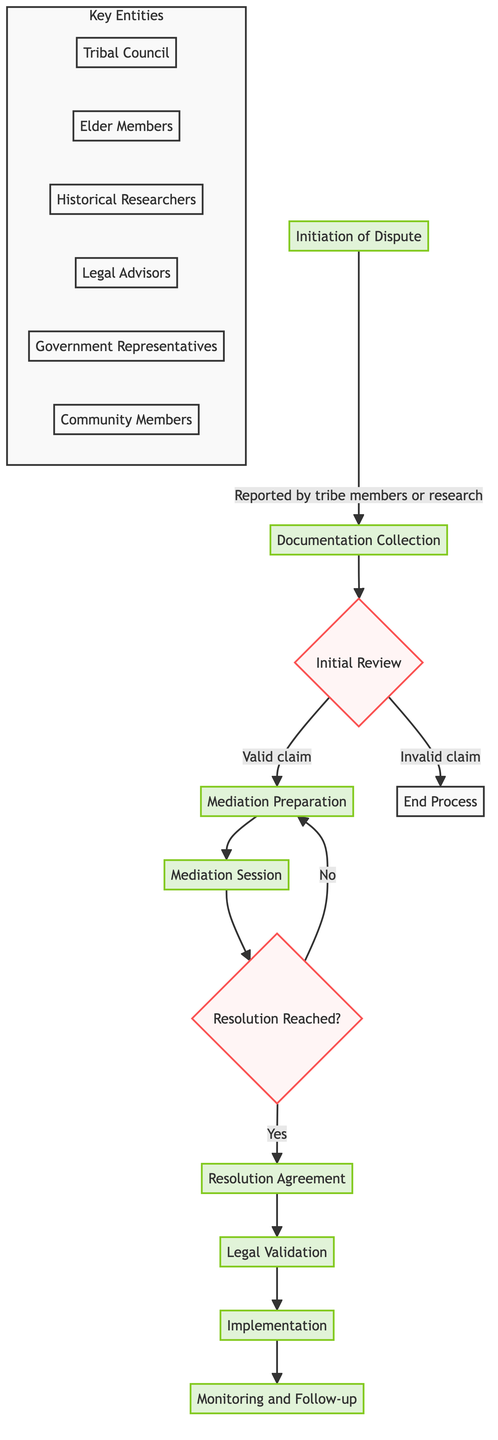What is the first step in the Tribal Land Dispute Resolution Process? The diagram shows that the first step is the "Initiation of Dispute," where a land dispute is identified.
Answer: Initiation of Dispute Which entity is responsible for the initial review of the dispute? The diagram indicates that the "Tribal Council" is responsible for the initial review as part of its role in the process.
Answer: Tribal Council How many steps are involved in the Tribal Land Dispute Resolution Process? By counting the steps listed in the diagram, there are a total of 9 steps in the process.
Answer: 9 What happens if the initial review determines the claim is invalid? According to the flowchart, if the claim is invalid, the process ends as indicated by the connection to "End Process."
Answer: End Process What action follows a successful mediation session? The flowchart shows that after a successful mediation session, the next action is drafting a "Resolution Agreement."
Answer: Resolution Agreement What is the purpose of the "Legal Validation" step? The diagram illustrates that the purpose of "Legal Validation" is to submit the resolution agreement for legal confirmation by authorities.
Answer: Submit for legal validation Which entity participates in mediation sessions? The flowchart lists "Community Members" as participants in the mediation sessions, indicating their role in supporting or disputing the resolution terms.
Answer: Community Members In what step is compliance ensured after the resolution agreement? The diagram states that after the agreement is implemented, the subsequent step is "Monitoring and Follow-up," which ensures ongoing compliance.
Answer: Monitoring and Follow-up Which step involves gathering historical documents and testimonies? The flowchart clearly outlines that the "Documentation Collection" step is where relevant historical documents and testimonies are gathered.
Answer: Documentation Collection 